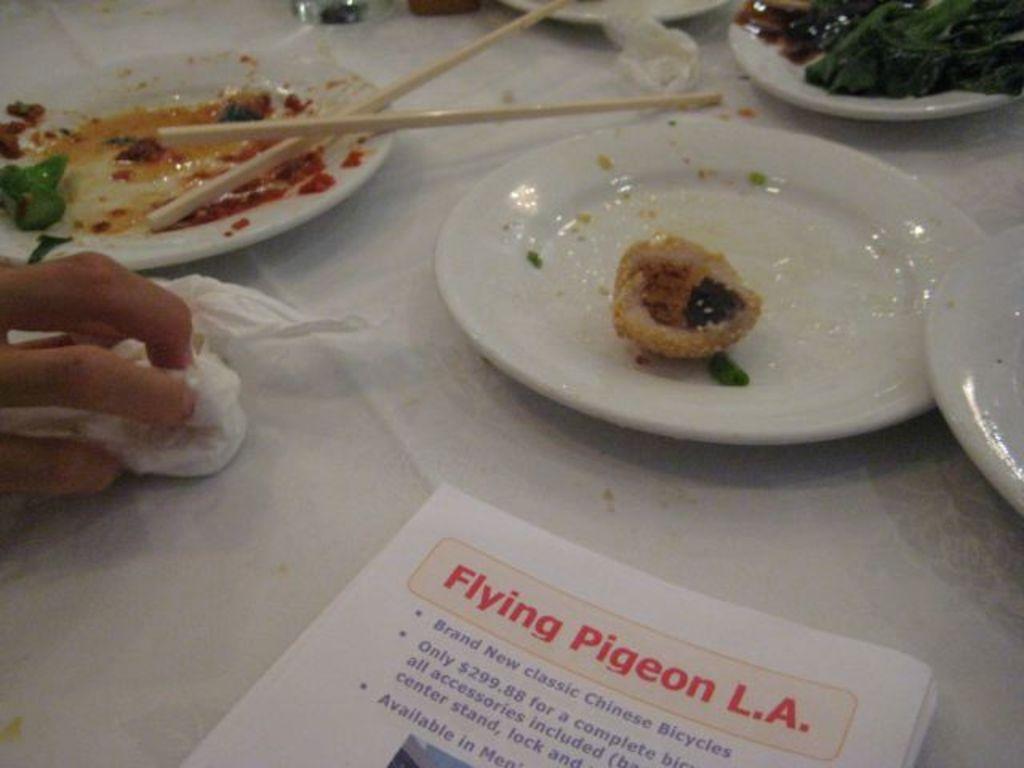How would you summarize this image in a sentence or two? This picture shows few plates, chopsticks and some food in the plates and we see papers and a human hand holding napkin on the table. 